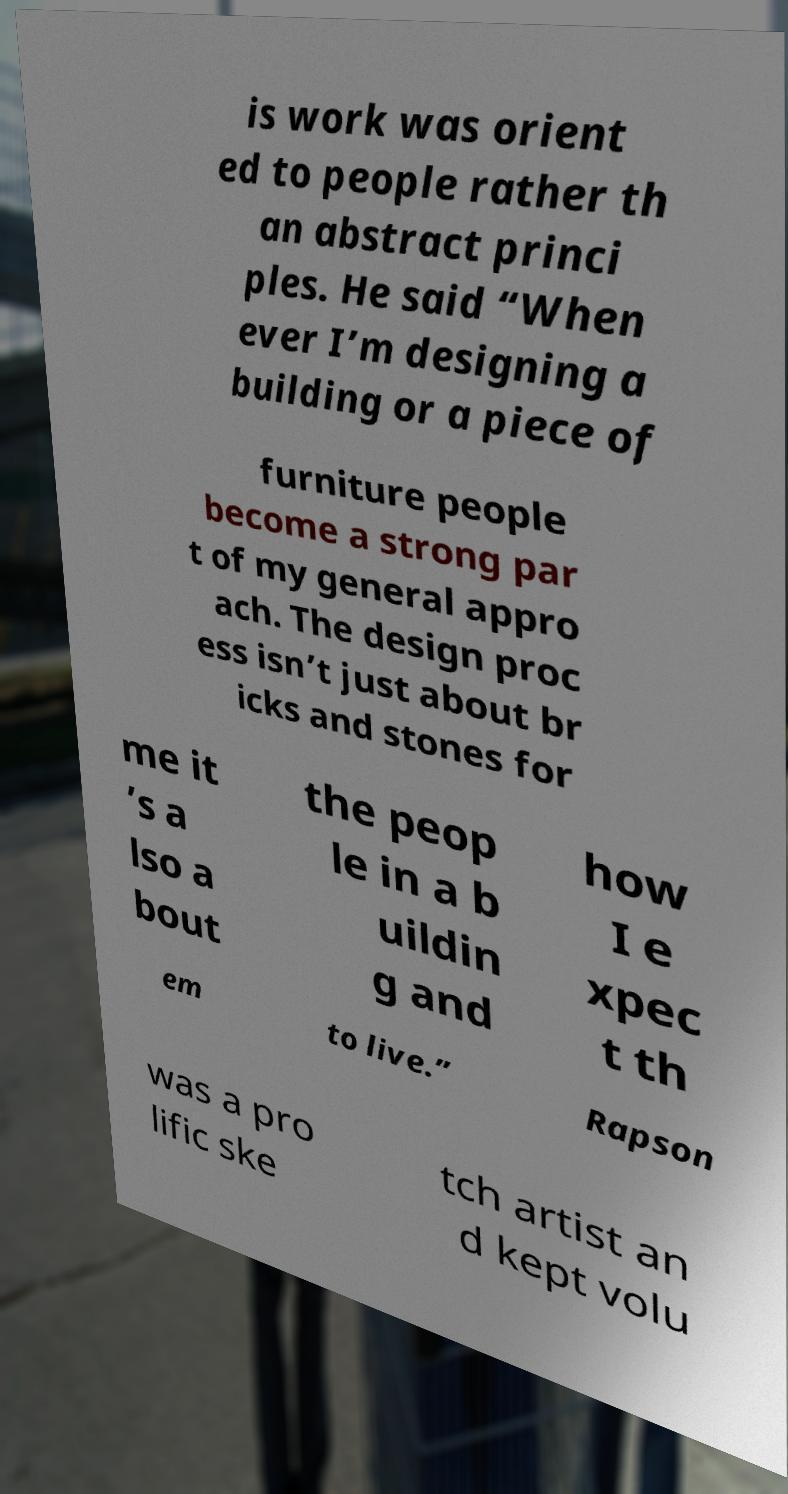Can you read and provide the text displayed in the image?This photo seems to have some interesting text. Can you extract and type it out for me? is work was orient ed to people rather th an abstract princi ples. He said “When ever I’m designing a building or a piece of furniture people become a strong par t of my general appro ach. The design proc ess isn’t just about br icks and stones for me it ’s a lso a bout the peop le in a b uildin g and how I e xpec t th em to live.” Rapson was a pro lific ske tch artist an d kept volu 